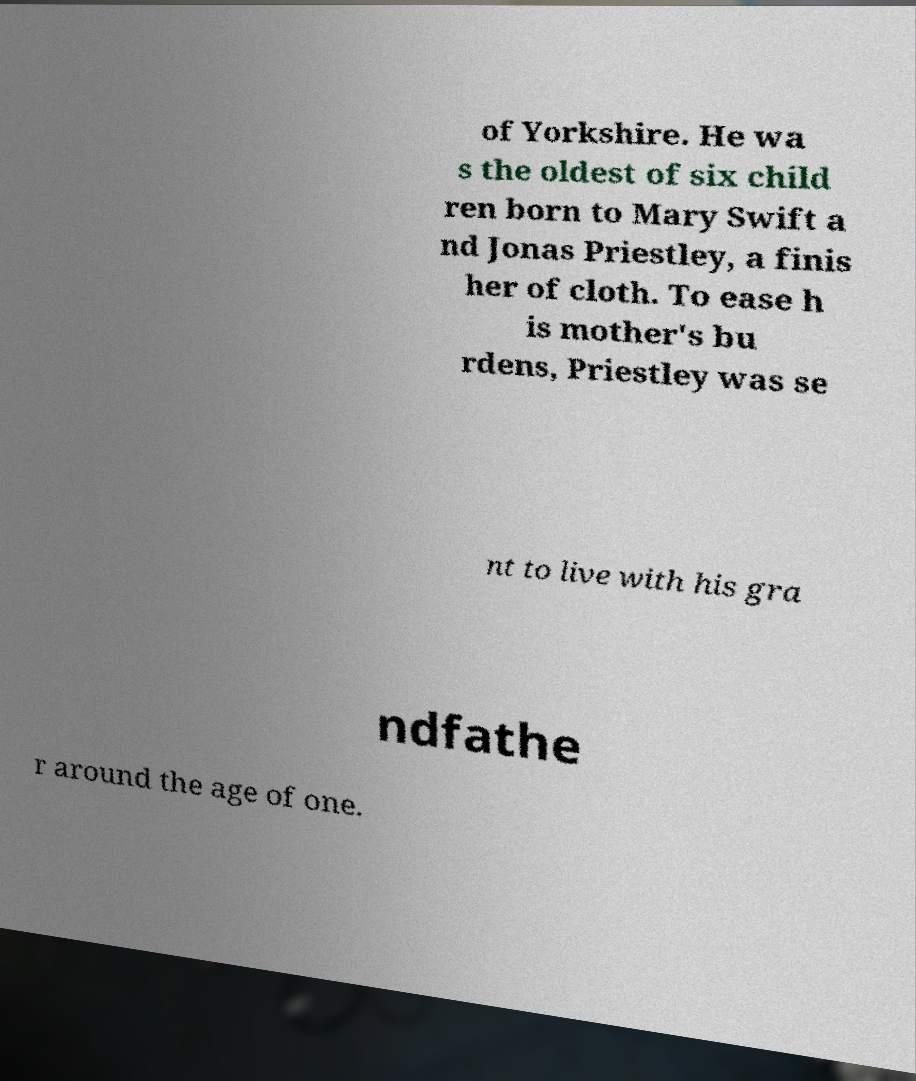Please read and relay the text visible in this image. What does it say? of Yorkshire. He wa s the oldest of six child ren born to Mary Swift a nd Jonas Priestley, a finis her of cloth. To ease h is mother's bu rdens, Priestley was se nt to live with his gra ndfathe r around the age of one. 